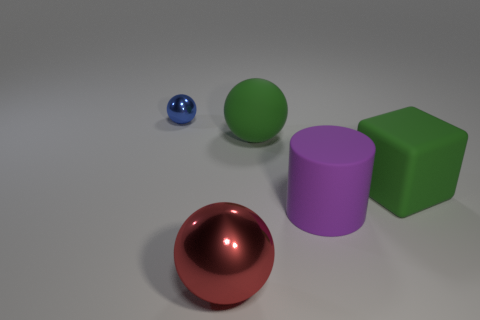Subtract all brown cubes. Subtract all yellow cylinders. How many cubes are left? 1 Add 1 blue metal spheres. How many objects exist? 6 Subtract all cylinders. How many objects are left? 4 Add 3 cubes. How many cubes are left? 4 Add 1 rubber cubes. How many rubber cubes exist? 2 Subtract 0 cyan cubes. How many objects are left? 5 Subtract all big green things. Subtract all big spheres. How many objects are left? 1 